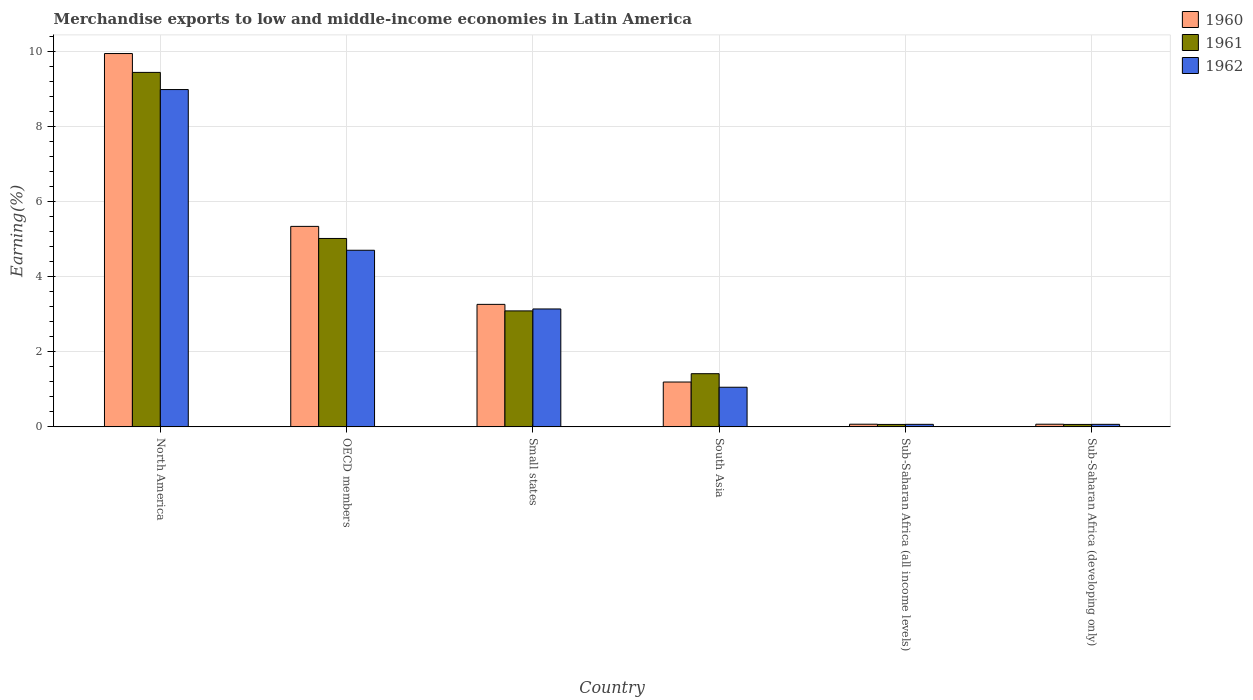Are the number of bars per tick equal to the number of legend labels?
Ensure brevity in your answer.  Yes. Are the number of bars on each tick of the X-axis equal?
Provide a short and direct response. Yes. How many bars are there on the 6th tick from the left?
Give a very brief answer. 3. What is the label of the 6th group of bars from the left?
Your answer should be very brief. Sub-Saharan Africa (developing only). What is the percentage of amount earned from merchandise exports in 1961 in Sub-Saharan Africa (all income levels)?
Give a very brief answer. 0.07. Across all countries, what is the maximum percentage of amount earned from merchandise exports in 1962?
Your answer should be very brief. 8.98. Across all countries, what is the minimum percentage of amount earned from merchandise exports in 1961?
Your answer should be very brief. 0.07. In which country was the percentage of amount earned from merchandise exports in 1962 maximum?
Provide a short and direct response. North America. In which country was the percentage of amount earned from merchandise exports in 1960 minimum?
Offer a terse response. Sub-Saharan Africa (all income levels). What is the total percentage of amount earned from merchandise exports in 1962 in the graph?
Your answer should be very brief. 18.01. What is the difference between the percentage of amount earned from merchandise exports in 1962 in South Asia and that in Sub-Saharan Africa (all income levels)?
Offer a terse response. 0.99. What is the difference between the percentage of amount earned from merchandise exports in 1960 in Sub-Saharan Africa (developing only) and the percentage of amount earned from merchandise exports in 1962 in North America?
Your answer should be very brief. -8.91. What is the average percentage of amount earned from merchandise exports in 1960 per country?
Your answer should be compact. 3.31. What is the difference between the percentage of amount earned from merchandise exports of/in 1962 and percentage of amount earned from merchandise exports of/in 1960 in Sub-Saharan Africa (developing only)?
Keep it short and to the point. -0. Is the percentage of amount earned from merchandise exports in 1960 in North America less than that in Sub-Saharan Africa (developing only)?
Provide a short and direct response. No. Is the difference between the percentage of amount earned from merchandise exports in 1962 in Small states and South Asia greater than the difference between the percentage of amount earned from merchandise exports in 1960 in Small states and South Asia?
Provide a succinct answer. Yes. What is the difference between the highest and the second highest percentage of amount earned from merchandise exports in 1962?
Make the answer very short. 5.84. What is the difference between the highest and the lowest percentage of amount earned from merchandise exports in 1962?
Provide a succinct answer. 8.91. Is the sum of the percentage of amount earned from merchandise exports in 1962 in South Asia and Sub-Saharan Africa (developing only) greater than the maximum percentage of amount earned from merchandise exports in 1960 across all countries?
Offer a very short reply. No. How many bars are there?
Provide a short and direct response. 18. What is the difference between two consecutive major ticks on the Y-axis?
Make the answer very short. 2. Are the values on the major ticks of Y-axis written in scientific E-notation?
Your answer should be compact. No. Where does the legend appear in the graph?
Your answer should be compact. Top right. How many legend labels are there?
Provide a short and direct response. 3. How are the legend labels stacked?
Your answer should be compact. Vertical. What is the title of the graph?
Your answer should be very brief. Merchandise exports to low and middle-income economies in Latin America. Does "2003" appear as one of the legend labels in the graph?
Your answer should be very brief. No. What is the label or title of the X-axis?
Provide a short and direct response. Country. What is the label or title of the Y-axis?
Make the answer very short. Earning(%). What is the Earning(%) of 1960 in North America?
Your answer should be compact. 9.94. What is the Earning(%) in 1961 in North America?
Ensure brevity in your answer.  9.44. What is the Earning(%) in 1962 in North America?
Provide a short and direct response. 8.98. What is the Earning(%) in 1960 in OECD members?
Give a very brief answer. 5.34. What is the Earning(%) in 1961 in OECD members?
Provide a short and direct response. 5.02. What is the Earning(%) of 1962 in OECD members?
Provide a succinct answer. 4.7. What is the Earning(%) in 1960 in Small states?
Keep it short and to the point. 3.26. What is the Earning(%) of 1961 in Small states?
Ensure brevity in your answer.  3.09. What is the Earning(%) in 1962 in Small states?
Your answer should be very brief. 3.14. What is the Earning(%) in 1960 in South Asia?
Keep it short and to the point. 1.19. What is the Earning(%) in 1961 in South Asia?
Your answer should be very brief. 1.42. What is the Earning(%) of 1962 in South Asia?
Your answer should be very brief. 1.05. What is the Earning(%) in 1960 in Sub-Saharan Africa (all income levels)?
Keep it short and to the point. 0.07. What is the Earning(%) of 1961 in Sub-Saharan Africa (all income levels)?
Keep it short and to the point. 0.07. What is the Earning(%) in 1962 in Sub-Saharan Africa (all income levels)?
Your answer should be very brief. 0.07. What is the Earning(%) of 1960 in Sub-Saharan Africa (developing only)?
Offer a terse response. 0.07. What is the Earning(%) in 1961 in Sub-Saharan Africa (developing only)?
Provide a succinct answer. 0.07. What is the Earning(%) of 1962 in Sub-Saharan Africa (developing only)?
Make the answer very short. 0.07. Across all countries, what is the maximum Earning(%) in 1960?
Your response must be concise. 9.94. Across all countries, what is the maximum Earning(%) of 1961?
Your answer should be very brief. 9.44. Across all countries, what is the maximum Earning(%) in 1962?
Your response must be concise. 8.98. Across all countries, what is the minimum Earning(%) of 1960?
Your response must be concise. 0.07. Across all countries, what is the minimum Earning(%) in 1961?
Offer a terse response. 0.07. Across all countries, what is the minimum Earning(%) of 1962?
Provide a short and direct response. 0.07. What is the total Earning(%) in 1960 in the graph?
Ensure brevity in your answer.  19.87. What is the total Earning(%) of 1961 in the graph?
Offer a very short reply. 19.08. What is the total Earning(%) in 1962 in the graph?
Your response must be concise. 18.01. What is the difference between the Earning(%) of 1960 in North America and that in OECD members?
Make the answer very short. 4.6. What is the difference between the Earning(%) of 1961 in North America and that in OECD members?
Provide a succinct answer. 4.42. What is the difference between the Earning(%) in 1962 in North America and that in OECD members?
Your answer should be very brief. 4.28. What is the difference between the Earning(%) of 1960 in North America and that in Small states?
Provide a succinct answer. 6.68. What is the difference between the Earning(%) of 1961 in North America and that in Small states?
Your answer should be compact. 6.35. What is the difference between the Earning(%) of 1962 in North America and that in Small states?
Provide a short and direct response. 5.84. What is the difference between the Earning(%) in 1960 in North America and that in South Asia?
Provide a succinct answer. 8.74. What is the difference between the Earning(%) of 1961 in North America and that in South Asia?
Keep it short and to the point. 8.02. What is the difference between the Earning(%) in 1962 in North America and that in South Asia?
Ensure brevity in your answer.  7.92. What is the difference between the Earning(%) in 1960 in North America and that in Sub-Saharan Africa (all income levels)?
Your answer should be compact. 9.87. What is the difference between the Earning(%) of 1961 in North America and that in Sub-Saharan Africa (all income levels)?
Offer a very short reply. 9.37. What is the difference between the Earning(%) in 1962 in North America and that in Sub-Saharan Africa (all income levels)?
Your answer should be very brief. 8.91. What is the difference between the Earning(%) of 1960 in North America and that in Sub-Saharan Africa (developing only)?
Ensure brevity in your answer.  9.87. What is the difference between the Earning(%) of 1961 in North America and that in Sub-Saharan Africa (developing only)?
Your answer should be very brief. 9.37. What is the difference between the Earning(%) in 1962 in North America and that in Sub-Saharan Africa (developing only)?
Your response must be concise. 8.91. What is the difference between the Earning(%) in 1960 in OECD members and that in Small states?
Offer a terse response. 2.08. What is the difference between the Earning(%) of 1961 in OECD members and that in Small states?
Provide a short and direct response. 1.93. What is the difference between the Earning(%) in 1962 in OECD members and that in Small states?
Your answer should be very brief. 1.56. What is the difference between the Earning(%) in 1960 in OECD members and that in South Asia?
Give a very brief answer. 4.14. What is the difference between the Earning(%) in 1961 in OECD members and that in South Asia?
Offer a very short reply. 3.6. What is the difference between the Earning(%) in 1962 in OECD members and that in South Asia?
Offer a terse response. 3.65. What is the difference between the Earning(%) in 1960 in OECD members and that in Sub-Saharan Africa (all income levels)?
Your response must be concise. 5.27. What is the difference between the Earning(%) of 1961 in OECD members and that in Sub-Saharan Africa (all income levels)?
Keep it short and to the point. 4.95. What is the difference between the Earning(%) in 1962 in OECD members and that in Sub-Saharan Africa (all income levels)?
Keep it short and to the point. 4.63. What is the difference between the Earning(%) of 1960 in OECD members and that in Sub-Saharan Africa (developing only)?
Give a very brief answer. 5.27. What is the difference between the Earning(%) in 1961 in OECD members and that in Sub-Saharan Africa (developing only)?
Offer a terse response. 4.95. What is the difference between the Earning(%) of 1962 in OECD members and that in Sub-Saharan Africa (developing only)?
Your answer should be very brief. 4.63. What is the difference between the Earning(%) in 1960 in Small states and that in South Asia?
Offer a terse response. 2.07. What is the difference between the Earning(%) in 1961 in Small states and that in South Asia?
Provide a short and direct response. 1.67. What is the difference between the Earning(%) of 1962 in Small states and that in South Asia?
Provide a short and direct response. 2.08. What is the difference between the Earning(%) in 1960 in Small states and that in Sub-Saharan Africa (all income levels)?
Offer a very short reply. 3.19. What is the difference between the Earning(%) in 1961 in Small states and that in Sub-Saharan Africa (all income levels)?
Provide a short and direct response. 3.02. What is the difference between the Earning(%) of 1962 in Small states and that in Sub-Saharan Africa (all income levels)?
Offer a terse response. 3.07. What is the difference between the Earning(%) in 1960 in Small states and that in Sub-Saharan Africa (developing only)?
Make the answer very short. 3.19. What is the difference between the Earning(%) of 1961 in Small states and that in Sub-Saharan Africa (developing only)?
Offer a very short reply. 3.02. What is the difference between the Earning(%) of 1962 in Small states and that in Sub-Saharan Africa (developing only)?
Provide a short and direct response. 3.07. What is the difference between the Earning(%) of 1960 in South Asia and that in Sub-Saharan Africa (all income levels)?
Give a very brief answer. 1.12. What is the difference between the Earning(%) of 1961 in South Asia and that in Sub-Saharan Africa (all income levels)?
Provide a short and direct response. 1.35. What is the difference between the Earning(%) in 1962 in South Asia and that in Sub-Saharan Africa (all income levels)?
Offer a terse response. 0.99. What is the difference between the Earning(%) in 1960 in South Asia and that in Sub-Saharan Africa (developing only)?
Provide a short and direct response. 1.12. What is the difference between the Earning(%) of 1961 in South Asia and that in Sub-Saharan Africa (developing only)?
Ensure brevity in your answer.  1.35. What is the difference between the Earning(%) in 1962 in South Asia and that in Sub-Saharan Africa (developing only)?
Your response must be concise. 0.99. What is the difference between the Earning(%) of 1960 in Sub-Saharan Africa (all income levels) and that in Sub-Saharan Africa (developing only)?
Provide a succinct answer. 0. What is the difference between the Earning(%) of 1961 in Sub-Saharan Africa (all income levels) and that in Sub-Saharan Africa (developing only)?
Offer a terse response. 0. What is the difference between the Earning(%) of 1960 in North America and the Earning(%) of 1961 in OECD members?
Keep it short and to the point. 4.92. What is the difference between the Earning(%) in 1960 in North America and the Earning(%) in 1962 in OECD members?
Offer a very short reply. 5.24. What is the difference between the Earning(%) in 1961 in North America and the Earning(%) in 1962 in OECD members?
Make the answer very short. 4.73. What is the difference between the Earning(%) in 1960 in North America and the Earning(%) in 1961 in Small states?
Ensure brevity in your answer.  6.85. What is the difference between the Earning(%) of 1960 in North America and the Earning(%) of 1962 in Small states?
Offer a very short reply. 6.8. What is the difference between the Earning(%) of 1961 in North America and the Earning(%) of 1962 in Small states?
Provide a short and direct response. 6.3. What is the difference between the Earning(%) of 1960 in North America and the Earning(%) of 1961 in South Asia?
Ensure brevity in your answer.  8.52. What is the difference between the Earning(%) of 1960 in North America and the Earning(%) of 1962 in South Asia?
Make the answer very short. 8.88. What is the difference between the Earning(%) of 1961 in North America and the Earning(%) of 1962 in South Asia?
Give a very brief answer. 8.38. What is the difference between the Earning(%) in 1960 in North America and the Earning(%) in 1961 in Sub-Saharan Africa (all income levels)?
Provide a short and direct response. 9.87. What is the difference between the Earning(%) of 1960 in North America and the Earning(%) of 1962 in Sub-Saharan Africa (all income levels)?
Keep it short and to the point. 9.87. What is the difference between the Earning(%) of 1961 in North America and the Earning(%) of 1962 in Sub-Saharan Africa (all income levels)?
Give a very brief answer. 9.37. What is the difference between the Earning(%) in 1960 in North America and the Earning(%) in 1961 in Sub-Saharan Africa (developing only)?
Your response must be concise. 9.87. What is the difference between the Earning(%) of 1960 in North America and the Earning(%) of 1962 in Sub-Saharan Africa (developing only)?
Ensure brevity in your answer.  9.87. What is the difference between the Earning(%) of 1961 in North America and the Earning(%) of 1962 in Sub-Saharan Africa (developing only)?
Provide a succinct answer. 9.37. What is the difference between the Earning(%) in 1960 in OECD members and the Earning(%) in 1961 in Small states?
Your response must be concise. 2.25. What is the difference between the Earning(%) in 1960 in OECD members and the Earning(%) in 1962 in Small states?
Offer a very short reply. 2.2. What is the difference between the Earning(%) in 1961 in OECD members and the Earning(%) in 1962 in Small states?
Offer a very short reply. 1.88. What is the difference between the Earning(%) of 1960 in OECD members and the Earning(%) of 1961 in South Asia?
Provide a short and direct response. 3.92. What is the difference between the Earning(%) in 1960 in OECD members and the Earning(%) in 1962 in South Asia?
Offer a very short reply. 4.28. What is the difference between the Earning(%) in 1961 in OECD members and the Earning(%) in 1962 in South Asia?
Give a very brief answer. 3.96. What is the difference between the Earning(%) in 1960 in OECD members and the Earning(%) in 1961 in Sub-Saharan Africa (all income levels)?
Give a very brief answer. 5.27. What is the difference between the Earning(%) of 1960 in OECD members and the Earning(%) of 1962 in Sub-Saharan Africa (all income levels)?
Offer a terse response. 5.27. What is the difference between the Earning(%) of 1961 in OECD members and the Earning(%) of 1962 in Sub-Saharan Africa (all income levels)?
Offer a terse response. 4.95. What is the difference between the Earning(%) in 1960 in OECD members and the Earning(%) in 1961 in Sub-Saharan Africa (developing only)?
Provide a succinct answer. 5.27. What is the difference between the Earning(%) in 1960 in OECD members and the Earning(%) in 1962 in Sub-Saharan Africa (developing only)?
Your answer should be very brief. 5.27. What is the difference between the Earning(%) of 1961 in OECD members and the Earning(%) of 1962 in Sub-Saharan Africa (developing only)?
Offer a terse response. 4.95. What is the difference between the Earning(%) in 1960 in Small states and the Earning(%) in 1961 in South Asia?
Ensure brevity in your answer.  1.85. What is the difference between the Earning(%) of 1960 in Small states and the Earning(%) of 1962 in South Asia?
Provide a succinct answer. 2.21. What is the difference between the Earning(%) of 1961 in Small states and the Earning(%) of 1962 in South Asia?
Your answer should be very brief. 2.03. What is the difference between the Earning(%) of 1960 in Small states and the Earning(%) of 1961 in Sub-Saharan Africa (all income levels)?
Your response must be concise. 3.2. What is the difference between the Earning(%) of 1960 in Small states and the Earning(%) of 1962 in Sub-Saharan Africa (all income levels)?
Keep it short and to the point. 3.19. What is the difference between the Earning(%) in 1961 in Small states and the Earning(%) in 1962 in Sub-Saharan Africa (all income levels)?
Offer a terse response. 3.02. What is the difference between the Earning(%) in 1960 in Small states and the Earning(%) in 1961 in Sub-Saharan Africa (developing only)?
Offer a very short reply. 3.2. What is the difference between the Earning(%) of 1960 in Small states and the Earning(%) of 1962 in Sub-Saharan Africa (developing only)?
Ensure brevity in your answer.  3.19. What is the difference between the Earning(%) in 1961 in Small states and the Earning(%) in 1962 in Sub-Saharan Africa (developing only)?
Provide a short and direct response. 3.02. What is the difference between the Earning(%) of 1960 in South Asia and the Earning(%) of 1961 in Sub-Saharan Africa (all income levels)?
Make the answer very short. 1.13. What is the difference between the Earning(%) in 1960 in South Asia and the Earning(%) in 1962 in Sub-Saharan Africa (all income levels)?
Offer a very short reply. 1.13. What is the difference between the Earning(%) of 1961 in South Asia and the Earning(%) of 1962 in Sub-Saharan Africa (all income levels)?
Ensure brevity in your answer.  1.35. What is the difference between the Earning(%) of 1960 in South Asia and the Earning(%) of 1961 in Sub-Saharan Africa (developing only)?
Your answer should be very brief. 1.13. What is the difference between the Earning(%) in 1960 in South Asia and the Earning(%) in 1962 in Sub-Saharan Africa (developing only)?
Ensure brevity in your answer.  1.13. What is the difference between the Earning(%) in 1961 in South Asia and the Earning(%) in 1962 in Sub-Saharan Africa (developing only)?
Offer a very short reply. 1.35. What is the difference between the Earning(%) of 1960 in Sub-Saharan Africa (all income levels) and the Earning(%) of 1961 in Sub-Saharan Africa (developing only)?
Provide a short and direct response. 0.01. What is the difference between the Earning(%) of 1960 in Sub-Saharan Africa (all income levels) and the Earning(%) of 1962 in Sub-Saharan Africa (developing only)?
Offer a very short reply. 0. What is the difference between the Earning(%) of 1961 in Sub-Saharan Africa (all income levels) and the Earning(%) of 1962 in Sub-Saharan Africa (developing only)?
Give a very brief answer. -0. What is the average Earning(%) in 1960 per country?
Provide a succinct answer. 3.31. What is the average Earning(%) of 1961 per country?
Keep it short and to the point. 3.18. What is the average Earning(%) of 1962 per country?
Your response must be concise. 3. What is the difference between the Earning(%) in 1960 and Earning(%) in 1961 in North America?
Your answer should be very brief. 0.5. What is the difference between the Earning(%) of 1960 and Earning(%) of 1962 in North America?
Provide a succinct answer. 0.96. What is the difference between the Earning(%) of 1961 and Earning(%) of 1962 in North America?
Offer a very short reply. 0.46. What is the difference between the Earning(%) in 1960 and Earning(%) in 1961 in OECD members?
Your response must be concise. 0.32. What is the difference between the Earning(%) of 1960 and Earning(%) of 1962 in OECD members?
Offer a terse response. 0.64. What is the difference between the Earning(%) in 1961 and Earning(%) in 1962 in OECD members?
Provide a succinct answer. 0.31. What is the difference between the Earning(%) in 1960 and Earning(%) in 1961 in Small states?
Provide a short and direct response. 0.17. What is the difference between the Earning(%) of 1960 and Earning(%) of 1962 in Small states?
Provide a succinct answer. 0.12. What is the difference between the Earning(%) of 1961 and Earning(%) of 1962 in Small states?
Offer a very short reply. -0.05. What is the difference between the Earning(%) in 1960 and Earning(%) in 1961 in South Asia?
Give a very brief answer. -0.22. What is the difference between the Earning(%) of 1960 and Earning(%) of 1962 in South Asia?
Ensure brevity in your answer.  0.14. What is the difference between the Earning(%) in 1961 and Earning(%) in 1962 in South Asia?
Your response must be concise. 0.36. What is the difference between the Earning(%) of 1960 and Earning(%) of 1961 in Sub-Saharan Africa (all income levels)?
Ensure brevity in your answer.  0.01. What is the difference between the Earning(%) of 1960 and Earning(%) of 1962 in Sub-Saharan Africa (all income levels)?
Your answer should be very brief. 0. What is the difference between the Earning(%) in 1961 and Earning(%) in 1962 in Sub-Saharan Africa (all income levels)?
Offer a very short reply. -0. What is the difference between the Earning(%) of 1960 and Earning(%) of 1961 in Sub-Saharan Africa (developing only)?
Your response must be concise. 0.01. What is the difference between the Earning(%) in 1960 and Earning(%) in 1962 in Sub-Saharan Africa (developing only)?
Offer a very short reply. 0. What is the difference between the Earning(%) in 1961 and Earning(%) in 1962 in Sub-Saharan Africa (developing only)?
Offer a very short reply. -0. What is the ratio of the Earning(%) of 1960 in North America to that in OECD members?
Your response must be concise. 1.86. What is the ratio of the Earning(%) of 1961 in North America to that in OECD members?
Make the answer very short. 1.88. What is the ratio of the Earning(%) in 1962 in North America to that in OECD members?
Ensure brevity in your answer.  1.91. What is the ratio of the Earning(%) in 1960 in North America to that in Small states?
Provide a succinct answer. 3.05. What is the ratio of the Earning(%) in 1961 in North America to that in Small states?
Make the answer very short. 3.06. What is the ratio of the Earning(%) of 1962 in North America to that in Small states?
Give a very brief answer. 2.86. What is the ratio of the Earning(%) in 1960 in North America to that in South Asia?
Ensure brevity in your answer.  8.33. What is the ratio of the Earning(%) in 1961 in North America to that in South Asia?
Provide a short and direct response. 6.67. What is the ratio of the Earning(%) in 1962 in North America to that in South Asia?
Your answer should be compact. 8.51. What is the ratio of the Earning(%) in 1960 in North America to that in Sub-Saharan Africa (all income levels)?
Offer a terse response. 140.19. What is the ratio of the Earning(%) in 1961 in North America to that in Sub-Saharan Africa (all income levels)?
Your answer should be compact. 145.11. What is the ratio of the Earning(%) of 1962 in North America to that in Sub-Saharan Africa (all income levels)?
Make the answer very short. 132.71. What is the ratio of the Earning(%) in 1960 in North America to that in Sub-Saharan Africa (developing only)?
Offer a terse response. 140.19. What is the ratio of the Earning(%) of 1961 in North America to that in Sub-Saharan Africa (developing only)?
Your answer should be compact. 145.11. What is the ratio of the Earning(%) in 1962 in North America to that in Sub-Saharan Africa (developing only)?
Keep it short and to the point. 132.71. What is the ratio of the Earning(%) of 1960 in OECD members to that in Small states?
Keep it short and to the point. 1.64. What is the ratio of the Earning(%) in 1961 in OECD members to that in Small states?
Give a very brief answer. 1.62. What is the ratio of the Earning(%) of 1962 in OECD members to that in Small states?
Provide a short and direct response. 1.5. What is the ratio of the Earning(%) of 1960 in OECD members to that in South Asia?
Give a very brief answer. 4.47. What is the ratio of the Earning(%) of 1961 in OECD members to that in South Asia?
Provide a succinct answer. 3.54. What is the ratio of the Earning(%) of 1962 in OECD members to that in South Asia?
Offer a very short reply. 4.46. What is the ratio of the Earning(%) in 1960 in OECD members to that in Sub-Saharan Africa (all income levels)?
Provide a short and direct response. 75.29. What is the ratio of the Earning(%) of 1961 in OECD members to that in Sub-Saharan Africa (all income levels)?
Provide a succinct answer. 77.13. What is the ratio of the Earning(%) in 1962 in OECD members to that in Sub-Saharan Africa (all income levels)?
Give a very brief answer. 69.48. What is the ratio of the Earning(%) of 1960 in OECD members to that in Sub-Saharan Africa (developing only)?
Ensure brevity in your answer.  75.29. What is the ratio of the Earning(%) in 1961 in OECD members to that in Sub-Saharan Africa (developing only)?
Provide a short and direct response. 77.13. What is the ratio of the Earning(%) in 1962 in OECD members to that in Sub-Saharan Africa (developing only)?
Ensure brevity in your answer.  69.48. What is the ratio of the Earning(%) in 1960 in Small states to that in South Asia?
Your answer should be compact. 2.73. What is the ratio of the Earning(%) in 1961 in Small states to that in South Asia?
Provide a succinct answer. 2.18. What is the ratio of the Earning(%) in 1962 in Small states to that in South Asia?
Provide a short and direct response. 2.98. What is the ratio of the Earning(%) in 1960 in Small states to that in Sub-Saharan Africa (all income levels)?
Keep it short and to the point. 46. What is the ratio of the Earning(%) in 1961 in Small states to that in Sub-Saharan Africa (all income levels)?
Keep it short and to the point. 47.48. What is the ratio of the Earning(%) in 1962 in Small states to that in Sub-Saharan Africa (all income levels)?
Your answer should be compact. 46.39. What is the ratio of the Earning(%) of 1960 in Small states to that in Sub-Saharan Africa (developing only)?
Offer a very short reply. 46. What is the ratio of the Earning(%) in 1961 in Small states to that in Sub-Saharan Africa (developing only)?
Your answer should be compact. 47.48. What is the ratio of the Earning(%) in 1962 in Small states to that in Sub-Saharan Africa (developing only)?
Provide a succinct answer. 46.39. What is the ratio of the Earning(%) in 1960 in South Asia to that in Sub-Saharan Africa (all income levels)?
Provide a short and direct response. 16.84. What is the ratio of the Earning(%) in 1961 in South Asia to that in Sub-Saharan Africa (all income levels)?
Your answer should be very brief. 21.77. What is the ratio of the Earning(%) of 1962 in South Asia to that in Sub-Saharan Africa (all income levels)?
Offer a terse response. 15.59. What is the ratio of the Earning(%) in 1960 in South Asia to that in Sub-Saharan Africa (developing only)?
Ensure brevity in your answer.  16.84. What is the ratio of the Earning(%) of 1961 in South Asia to that in Sub-Saharan Africa (developing only)?
Provide a short and direct response. 21.77. What is the ratio of the Earning(%) in 1962 in South Asia to that in Sub-Saharan Africa (developing only)?
Give a very brief answer. 15.59. What is the difference between the highest and the second highest Earning(%) in 1960?
Offer a very short reply. 4.6. What is the difference between the highest and the second highest Earning(%) of 1961?
Keep it short and to the point. 4.42. What is the difference between the highest and the second highest Earning(%) of 1962?
Offer a very short reply. 4.28. What is the difference between the highest and the lowest Earning(%) of 1960?
Your response must be concise. 9.87. What is the difference between the highest and the lowest Earning(%) in 1961?
Make the answer very short. 9.37. What is the difference between the highest and the lowest Earning(%) in 1962?
Provide a succinct answer. 8.91. 